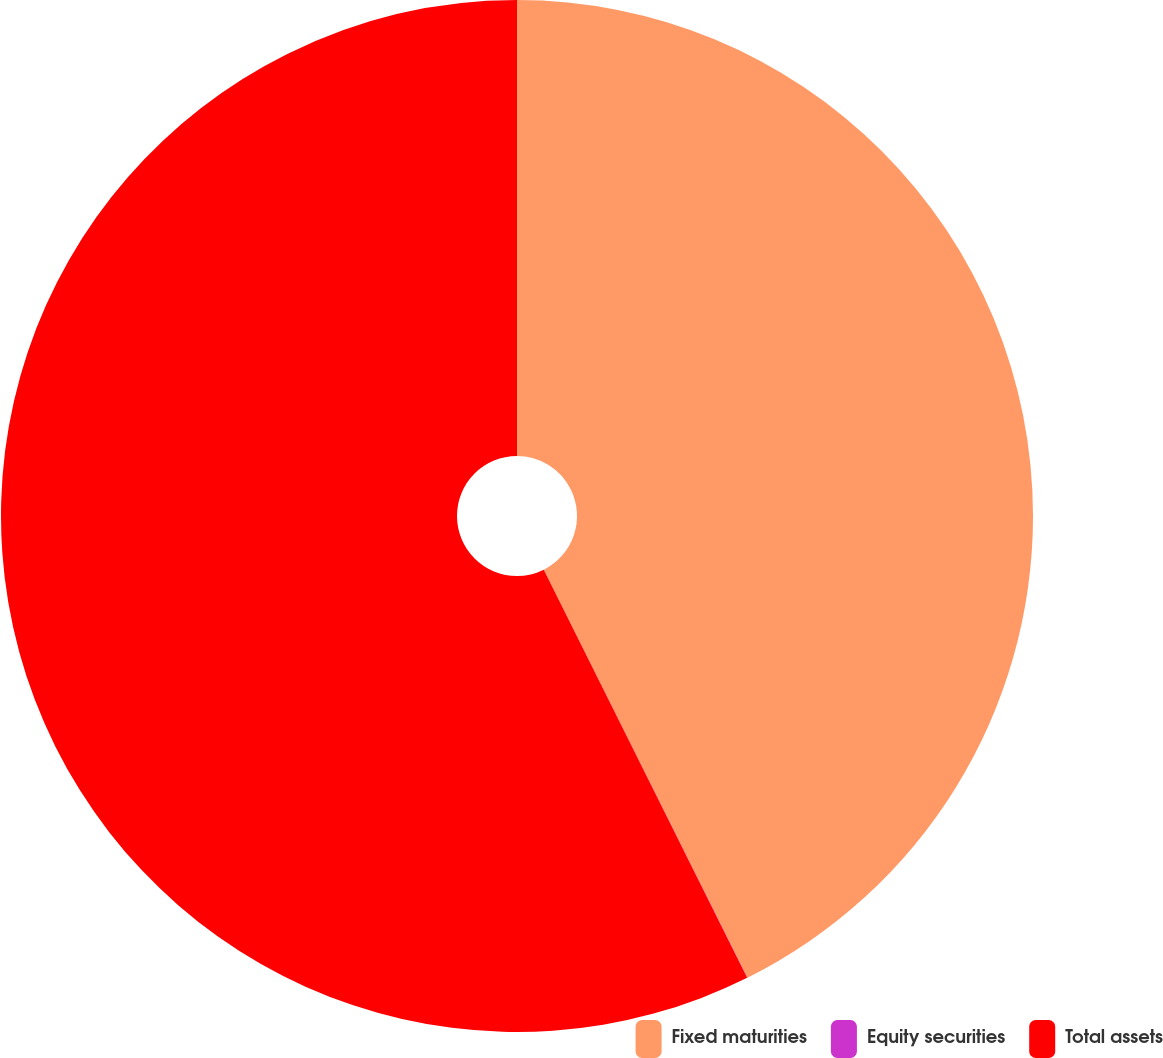<chart> <loc_0><loc_0><loc_500><loc_500><pie_chart><fcel>Fixed maturities<fcel>Equity securities<fcel>Total assets<nl><fcel>42.63%<fcel>0.01%<fcel>57.36%<nl></chart> 